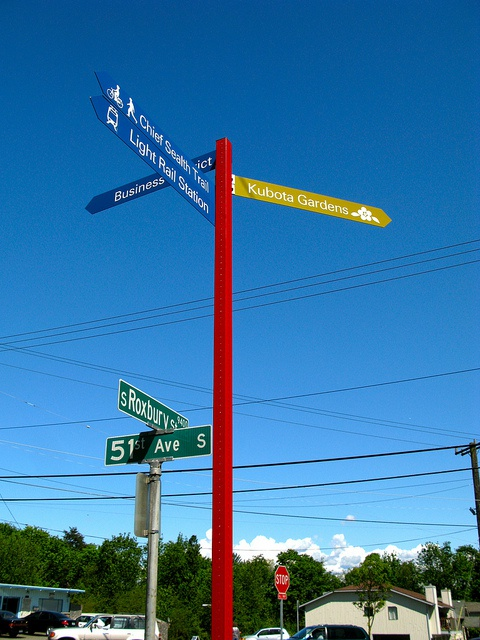Describe the objects in this image and their specific colors. I can see truck in blue, white, gray, black, and darkgray tones, car in blue, black, gray, and navy tones, car in blue, black, and darkblue tones, car in blue, white, black, darkgray, and lightblue tones, and stop sign in blue, brown, and salmon tones in this image. 